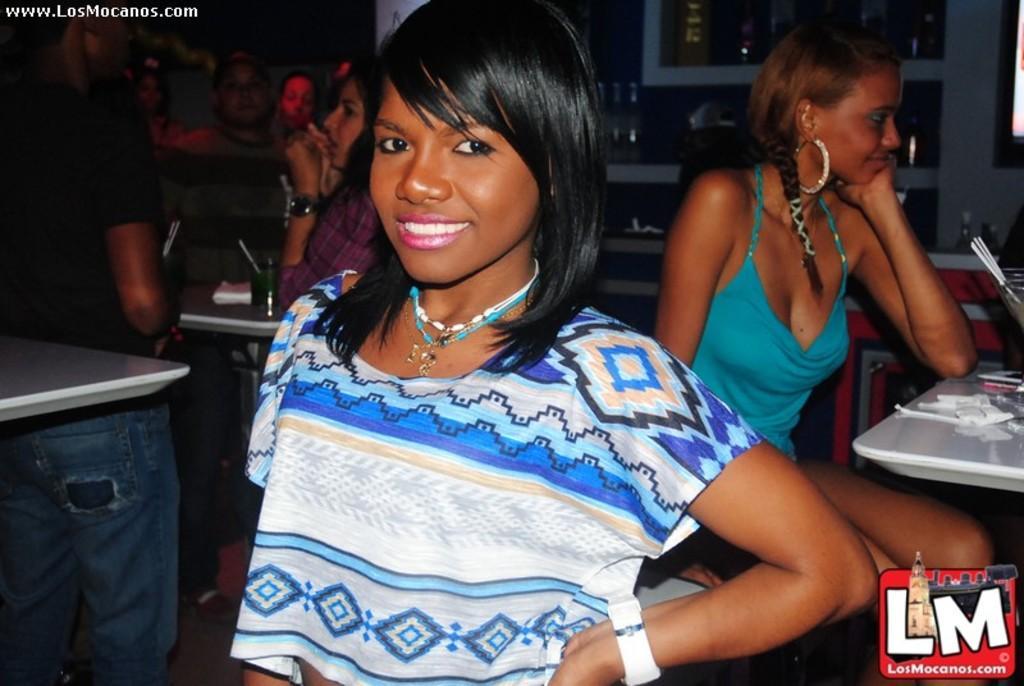How would you summarize this image in a sentence or two? In this image there is a person standing , and at the background there are group of people , a person standing, two persons siting on the chairs, there are some objects on the tables and on the racks, there are watermarks on the image. 